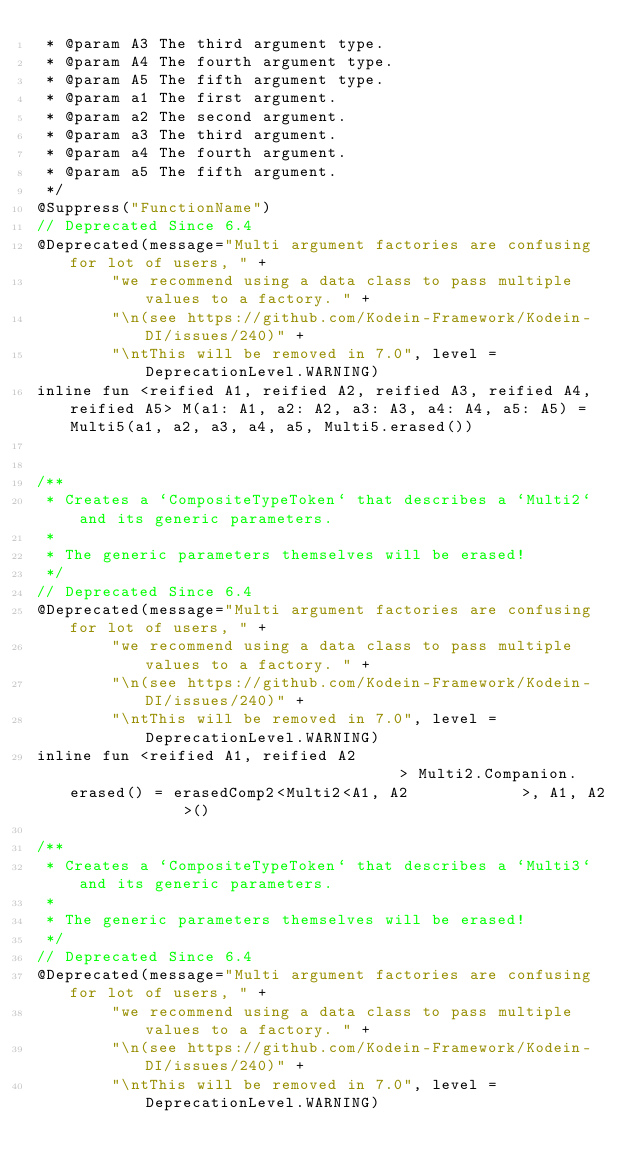Convert code to text. <code><loc_0><loc_0><loc_500><loc_500><_Kotlin_> * @param A3 The third argument type.
 * @param A4 The fourth argument type.
 * @param A5 The fifth argument type.
 * @param a1 The first argument.
 * @param a2 The second argument.
 * @param a3 The third argument.
 * @param a4 The fourth argument.
 * @param a5 The fifth argument.
 */
@Suppress("FunctionName")
// Deprecated Since 6.4
@Deprecated(message="Multi argument factories are confusing for lot of users, " +
        "we recommend using a data class to pass multiple values to a factory. " +
        "\n(see https://github.com/Kodein-Framework/Kodein-DI/issues/240)" +
        "\ntThis will be removed in 7.0", level = DeprecationLevel.WARNING)
inline fun <reified A1, reified A2, reified A3, reified A4, reified A5> M(a1: A1, a2: A2, a3: A3, a4: A4, a5: A5) = Multi5(a1, a2, a3, a4, a5, Multi5.erased())


/**
 * Creates a `CompositeTypeToken` that describes a `Multi2` and its generic parameters.
 *
 * The generic parameters themselves will be erased!
 */
// Deprecated Since 6.4
@Deprecated(message="Multi argument factories are confusing for lot of users, " +
        "we recommend using a data class to pass multiple values to a factory. " +
        "\n(see https://github.com/Kodein-Framework/Kodein-DI/issues/240)" +
        "\ntThis will be removed in 7.0", level = DeprecationLevel.WARNING)
inline fun <reified A1, reified A2                                    > Multi2.Companion.erased() = erasedComp2<Multi2<A1, A2            >, A1, A2            >()

/**
 * Creates a `CompositeTypeToken` that describes a `Multi3` and its generic parameters.
 *
 * The generic parameters themselves will be erased!
 */
// Deprecated Since 6.4
@Deprecated(message="Multi argument factories are confusing for lot of users, " +
        "we recommend using a data class to pass multiple values to a factory. " +
        "\n(see https://github.com/Kodein-Framework/Kodein-DI/issues/240)" +
        "\ntThis will be removed in 7.0", level = DeprecationLevel.WARNING)</code> 